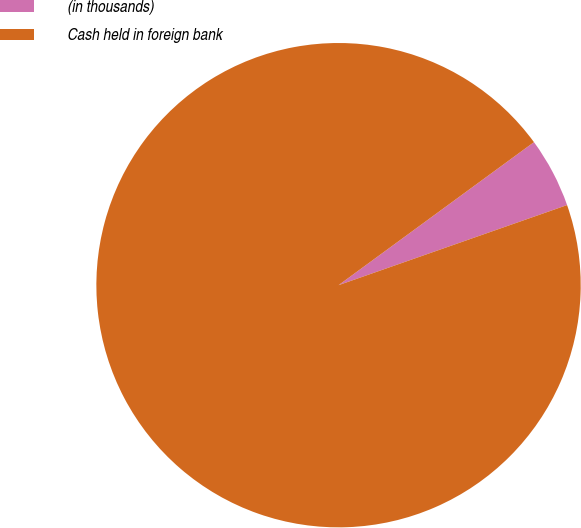<chart> <loc_0><loc_0><loc_500><loc_500><pie_chart><fcel>(in thousands)<fcel>Cash held in foreign bank<nl><fcel>4.69%<fcel>95.31%<nl></chart> 